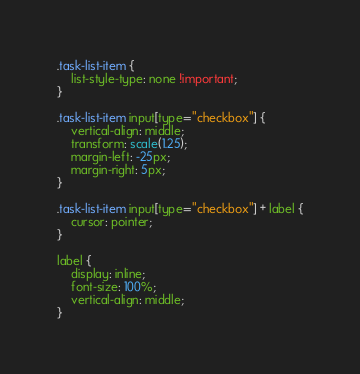<code> <loc_0><loc_0><loc_500><loc_500><_CSS_>.task-list-item {
	list-style-type: none !important;
}

.task-list-item input[type="checkbox"] {
	vertical-align: middle;
	transform: scale(1.25);
	margin-left: -25px;
	margin-right: 5px;
}

.task-list-item input[type="checkbox"] + label {
	cursor: pointer;
}

label {
	display: inline;
	font-size: 100%;
	vertical-align: middle;
}</code> 